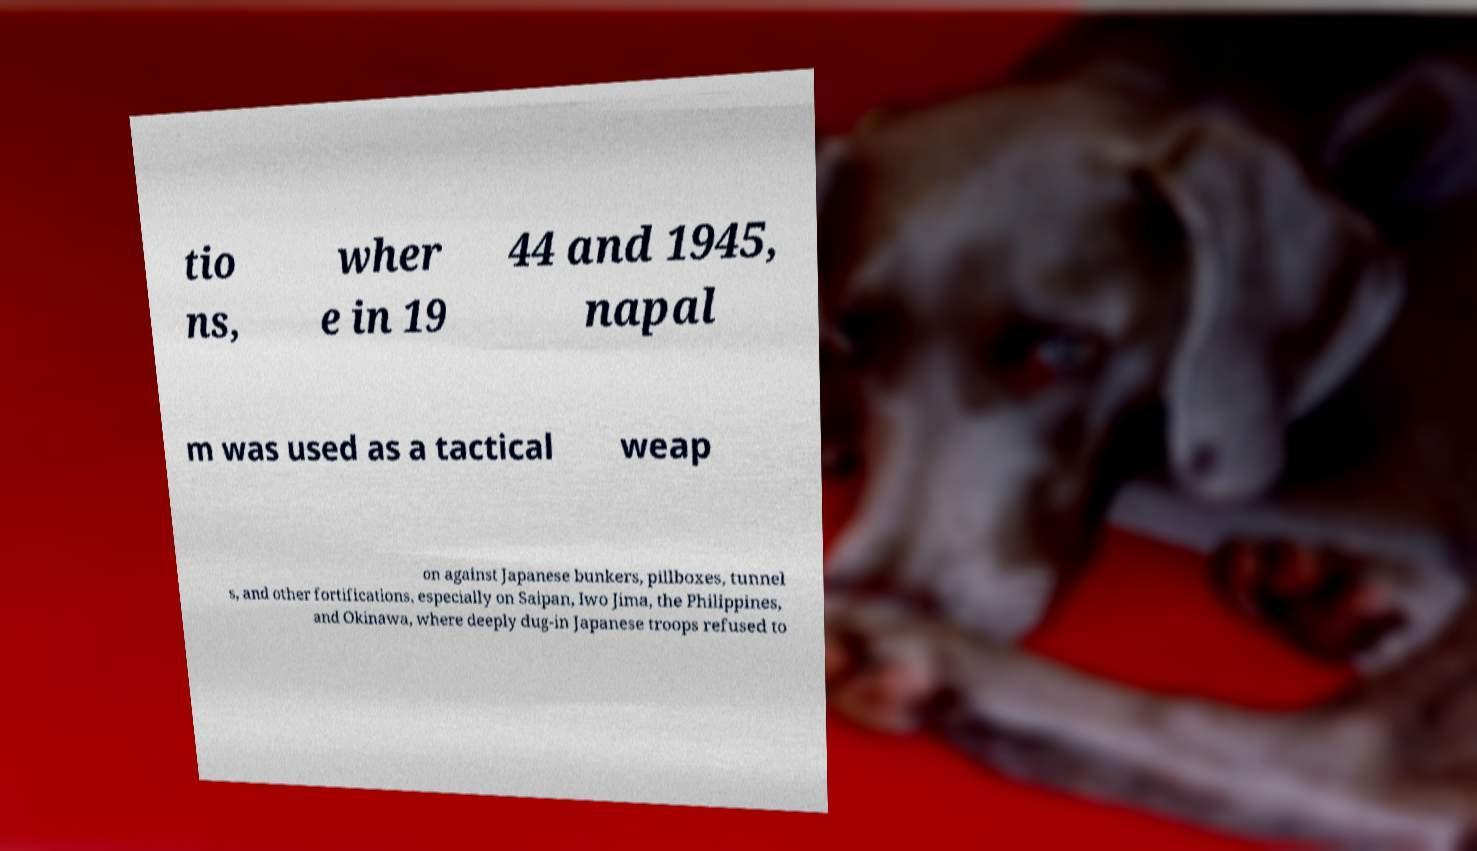Could you assist in decoding the text presented in this image and type it out clearly? tio ns, wher e in 19 44 and 1945, napal m was used as a tactical weap on against Japanese bunkers, pillboxes, tunnel s, and other fortifications, especially on Saipan, Iwo Jima, the Philippines, and Okinawa, where deeply dug-in Japanese troops refused to 